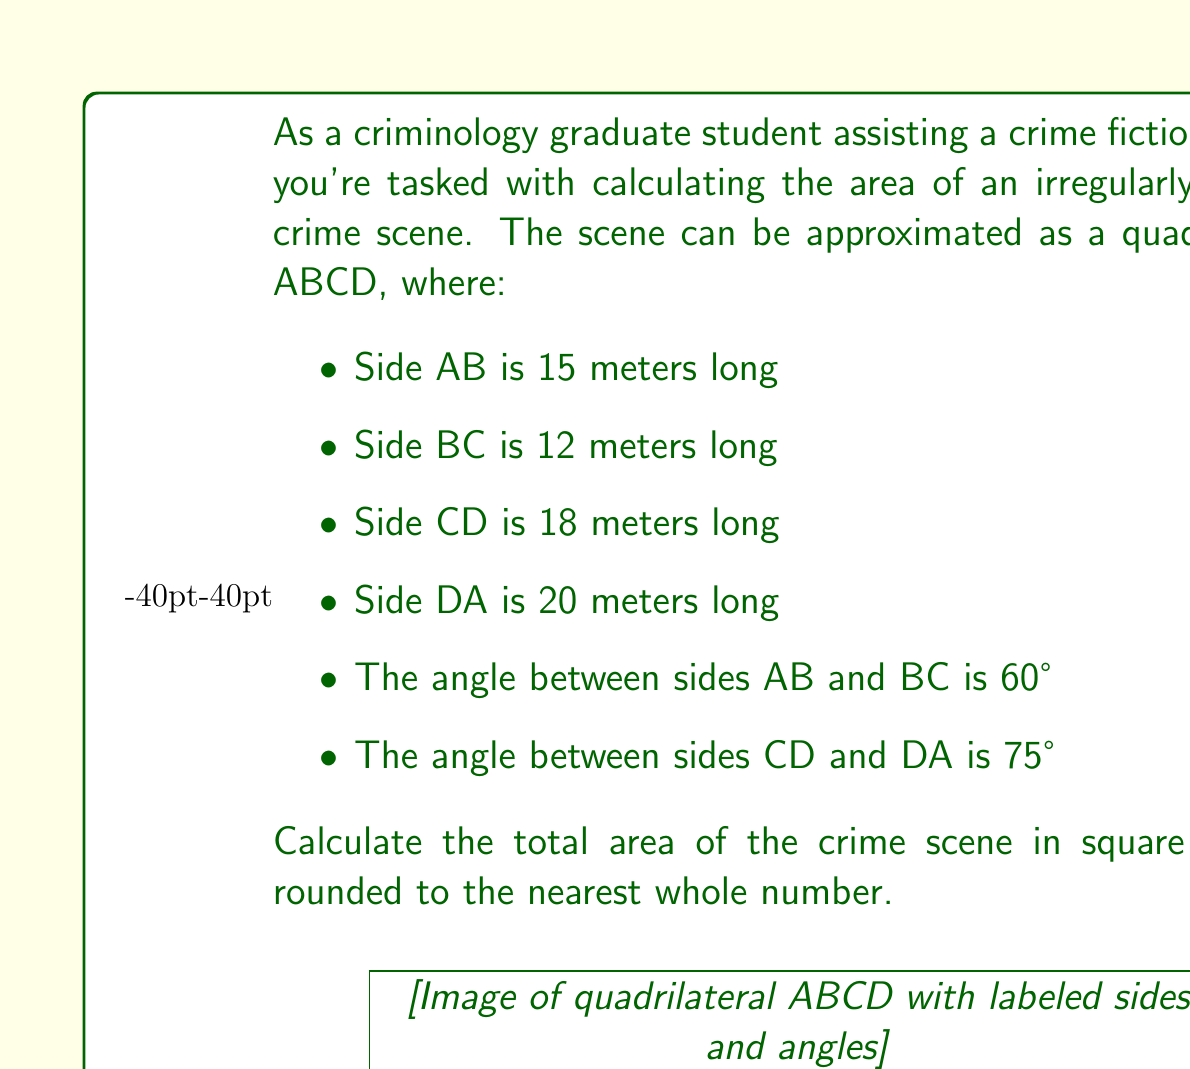Can you solve this math problem? To find the area of this irregular quadrilateral, we can split it into two triangles and use trigonometric functions to calculate their areas.

1. Split the quadrilateral into triangles ABC and ACD.

2. For triangle ABC:
   - We know two sides (AB = 15m, BC = 12m) and the included angle (60°).
   - Area of ABC = $\frac{1}{2} \cdot AB \cdot BC \cdot \sin(60°)$
   - Area of ABC = $\frac{1}{2} \cdot 15 \cdot 12 \cdot \frac{\sqrt{3}}{2} = 45\sqrt{3}$ m²

3. For triangle ACD:
   - We know two sides (CD = 18m, DA = 20m) and the included angle (75°).
   - Area of ACD = $\frac{1}{2} \cdot CD \cdot DA \cdot \sin(75°)$
   - Area of ACD = $\frac{1}{2} \cdot 18 \cdot 20 \cdot \frac{\sqrt{6}+\sqrt{2}}{4} = 45(\sqrt{6}+\sqrt{2})$ m²

4. Total area = Area of ABC + Area of ACD
   $$ \text{Total Area} = 45\sqrt{3} + 45(\sqrt{6}+\sqrt{2}) $$

5. Simplify and calculate:
   $$ \text{Total Area} = 45(\sqrt{3} + \sqrt{6} + \sqrt{2}) $$
   $$ \approx 45(1.732 + 2.449 + 1.414) $$
   $$ \approx 45 \cdot 5.595 $$
   $$ \approx 251.775 \text{ m²} $$

6. Rounding to the nearest whole number: 252 m²
Answer: 252 m² 